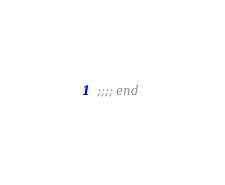<code> <loc_0><loc_0><loc_500><loc_500><_Lisp_>

;;;; end
</code> 